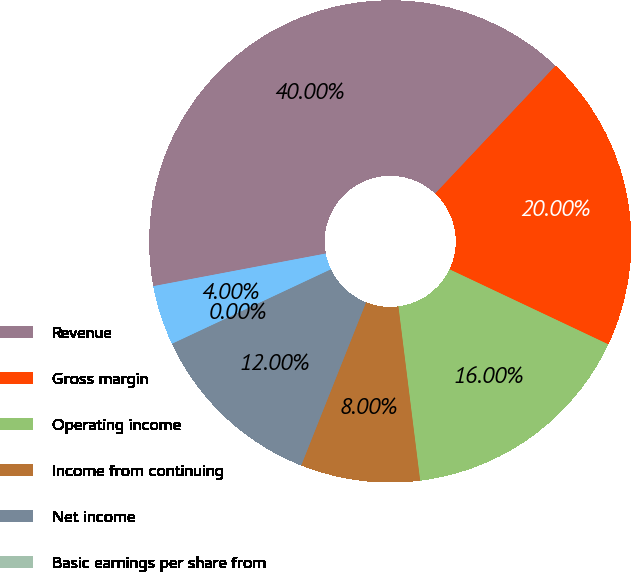Convert chart. <chart><loc_0><loc_0><loc_500><loc_500><pie_chart><fcel>Revenue<fcel>Gross margin<fcel>Operating income<fcel>Income from continuing<fcel>Net income<fcel>Basic earnings per share from<fcel>Diluted earnings per share<nl><fcel>40.0%<fcel>20.0%<fcel>16.0%<fcel>8.0%<fcel>12.0%<fcel>0.0%<fcel>4.0%<nl></chart> 